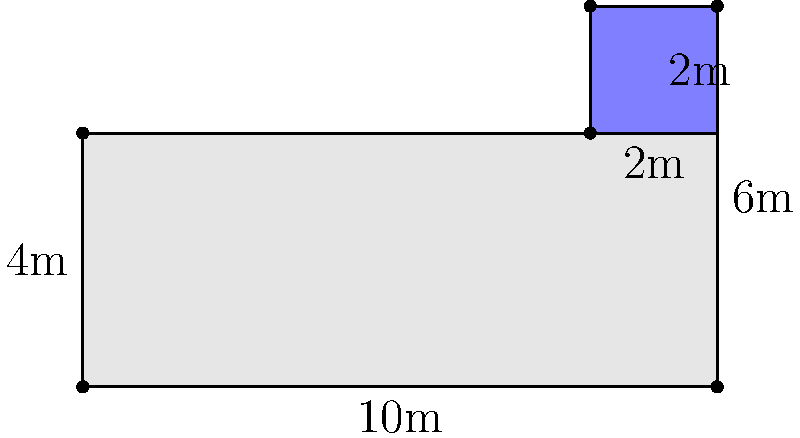As a seasoned engineer in the motorsports industry, you're tasked with optimizing the pit stop area for your team. The layout consists of a main pit area and a separate tool storage section. The main pit area is 10m long and 4m wide, with an additional 2m x 2m tool storage area attached to the upper right corner. What is the total area of this pit stop layout in square meters? Let's break this down step-by-step:

1. First, we need to calculate the area of the main pit area:
   $A_{main} = 10m \times 4m = 40m^2$

2. Next, we calculate the area of the tool storage section:
   $A_{tool} = 2m \times 2m = 4m^2$

3. The total area is the sum of these two areas:
   $A_{total} = A_{main} + A_{tool}$
   $A_{total} = 40m^2 + 4m^2 = 44m^2$

Therefore, the total area of the pit stop layout is 44 square meters.
Answer: $44m^2$ 